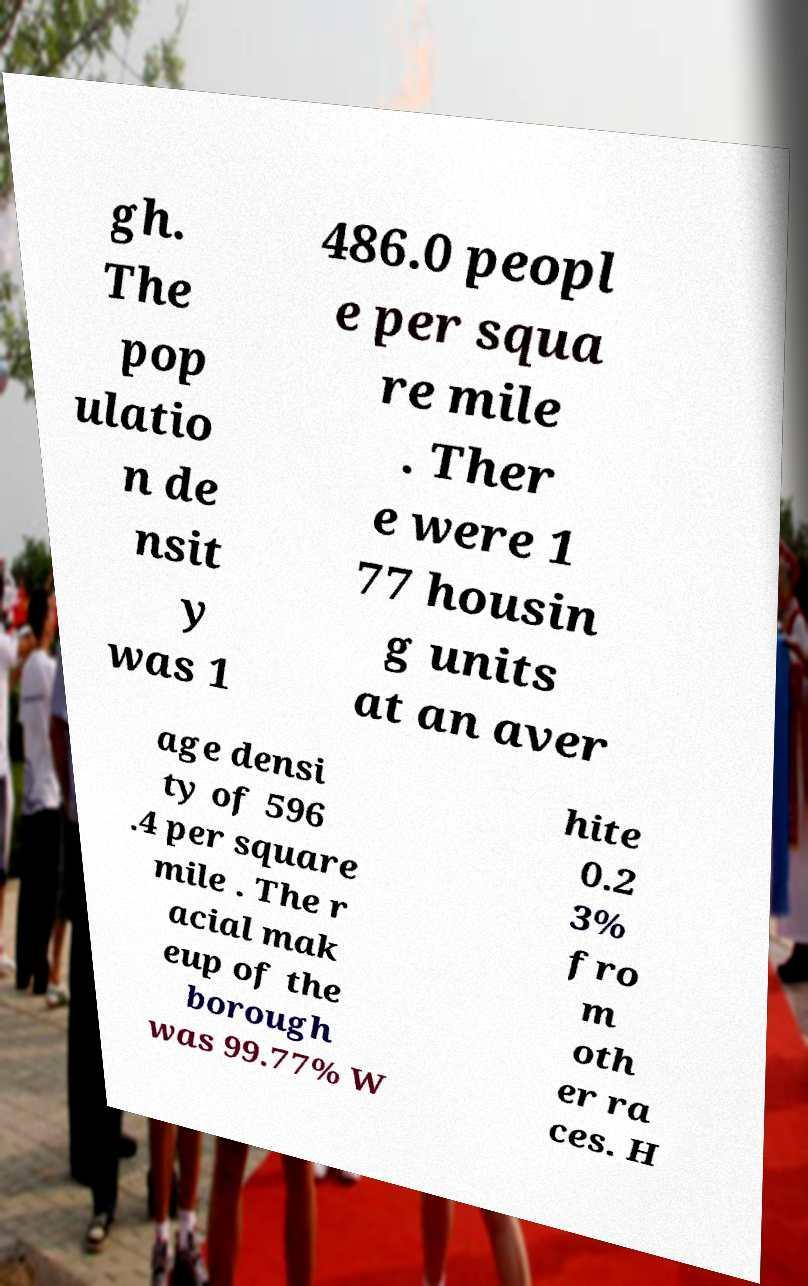There's text embedded in this image that I need extracted. Can you transcribe it verbatim? gh. The pop ulatio n de nsit y was 1 486.0 peopl e per squa re mile . Ther e were 1 77 housin g units at an aver age densi ty of 596 .4 per square mile . The r acial mak eup of the borough was 99.77% W hite 0.2 3% fro m oth er ra ces. H 